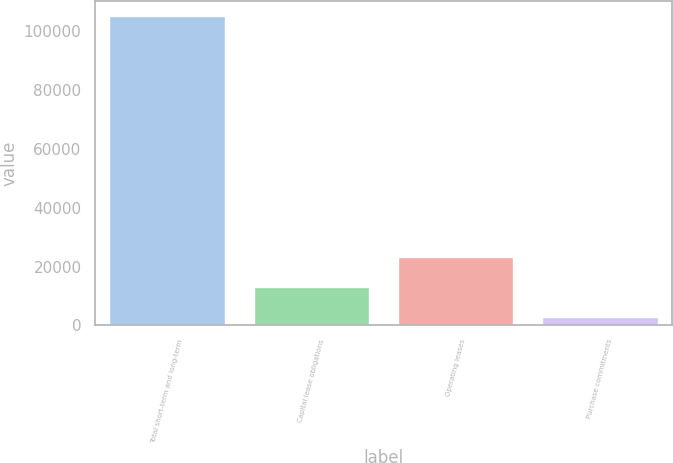Convert chart. <chart><loc_0><loc_0><loc_500><loc_500><bar_chart><fcel>Total short-term and long-term<fcel>Capital lease obligations<fcel>Operating leases<fcel>Purchase commitments<nl><fcel>105000<fcel>13174.8<fcel>23377.6<fcel>2972<nl></chart> 